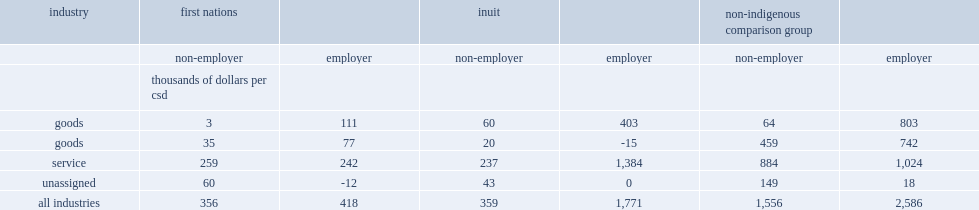Which industries did non-employers earn the highest profits per community for all three csd types? Service. Which industries did non-employers earn the highest profits per community for all three csd types? Service. 